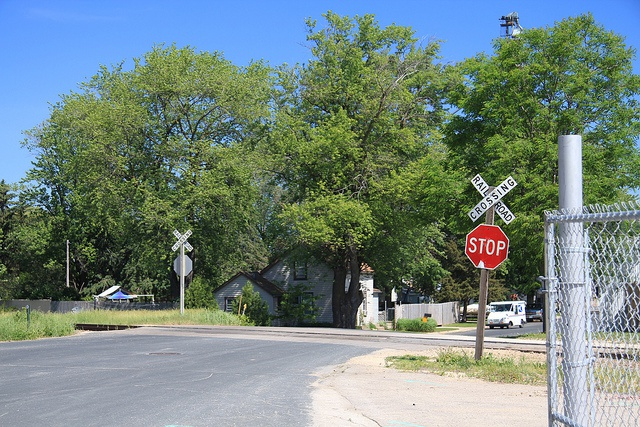Describe the objects in this image and their specific colors. I can see stop sign in lightblue, brown, and lightgray tones, truck in lightblue, white, black, darkgray, and navy tones, car in lightblue, black, gray, navy, and darkgray tones, and stop sign in lightblue, darkgray, gray, and lightgray tones in this image. 